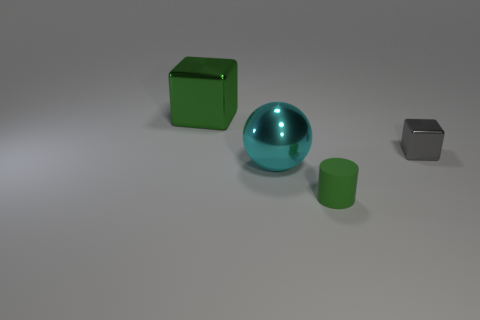Add 2 large cyan shiny cubes. How many objects exist? 6 Subtract all spheres. How many objects are left? 3 Add 4 small matte cylinders. How many small matte cylinders are left? 5 Add 4 purple rubber things. How many purple rubber things exist? 4 Subtract 0 brown blocks. How many objects are left? 4 Subtract all large red rubber cylinders. Subtract all green metallic cubes. How many objects are left? 3 